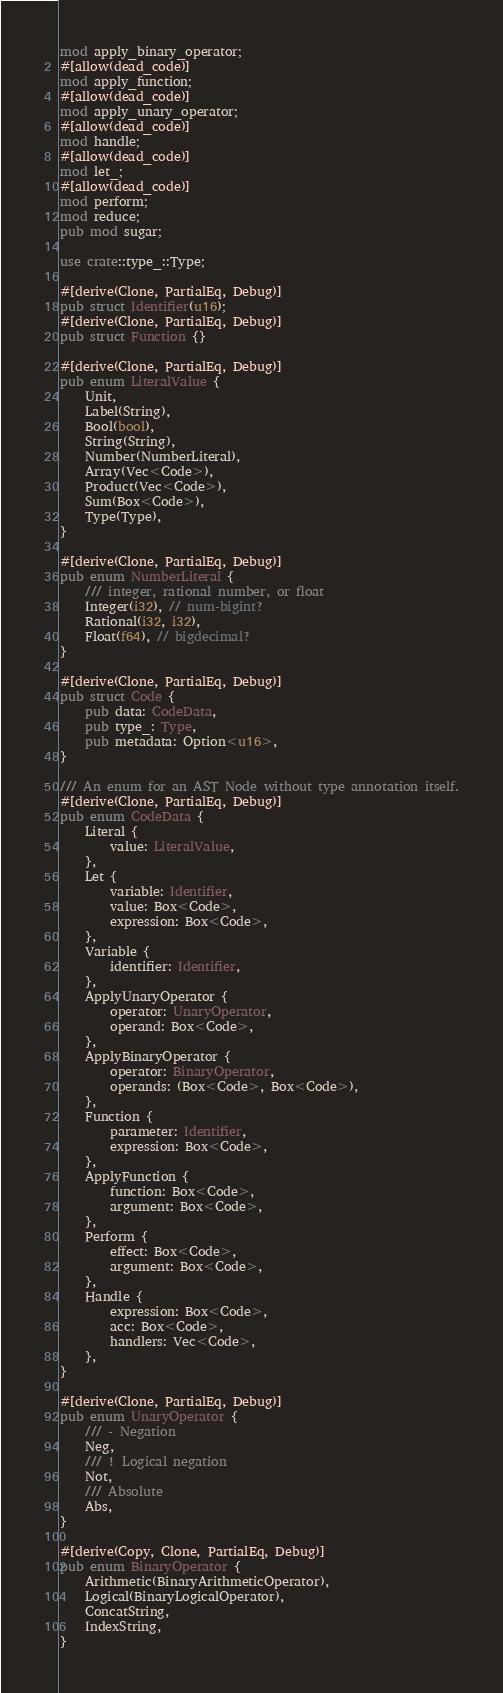Convert code to text. <code><loc_0><loc_0><loc_500><loc_500><_Rust_>mod apply_binary_operator;
#[allow(dead_code)]
mod apply_function;
#[allow(dead_code)]
mod apply_unary_operator;
#[allow(dead_code)]
mod handle;
#[allow(dead_code)]
mod let_;
#[allow(dead_code)]
mod perform;
mod reduce;
pub mod sugar;

use crate::type_::Type;

#[derive(Clone, PartialEq, Debug)]
pub struct Identifier(u16);
#[derive(Clone, PartialEq, Debug)]
pub struct Function {}

#[derive(Clone, PartialEq, Debug)]
pub enum LiteralValue {
    Unit,
    Label(String),
    Bool(bool),
    String(String),
    Number(NumberLiteral),
    Array(Vec<Code>),
    Product(Vec<Code>),
    Sum(Box<Code>),
    Type(Type),
}

#[derive(Clone, PartialEq, Debug)]
pub enum NumberLiteral {
    /// integer, rational number, or float
    Integer(i32), // num-bigint?
    Rational(i32, i32),
    Float(f64), // bigdecimal?
}

#[derive(Clone, PartialEq, Debug)]
pub struct Code {
    pub data: CodeData,
    pub type_: Type,
    pub metadata: Option<u16>,
}

/// An enum for an AST Node without type annotation itself.
#[derive(Clone, PartialEq, Debug)]
pub enum CodeData {
    Literal {
        value: LiteralValue,
    },
    Let {
        variable: Identifier,
        value: Box<Code>,
        expression: Box<Code>,
    },
    Variable {
        identifier: Identifier,
    },
    ApplyUnaryOperator {
        operator: UnaryOperator,
        operand: Box<Code>,
    },
    ApplyBinaryOperator {
        operator: BinaryOperator,
        operands: (Box<Code>, Box<Code>),
    },
    Function {
        parameter: Identifier,
        expression: Box<Code>,
    },
    ApplyFunction {
        function: Box<Code>,
        argument: Box<Code>,
    },
    Perform {
        effect: Box<Code>,
        argument: Box<Code>,
    },
    Handle {
        expression: Box<Code>,
        acc: Box<Code>,
        handlers: Vec<Code>,
    },
}

#[derive(Clone, PartialEq, Debug)]
pub enum UnaryOperator {
    /// - Negation
    Neg,
    /// ! Logical negation
    Not,
    /// Absolute
    Abs,
}

#[derive(Copy, Clone, PartialEq, Debug)]
pub enum BinaryOperator {
    Arithmetic(BinaryArithmeticOperator),
    Logical(BinaryLogicalOperator),
    ConcatString,
    IndexString,
}
</code> 